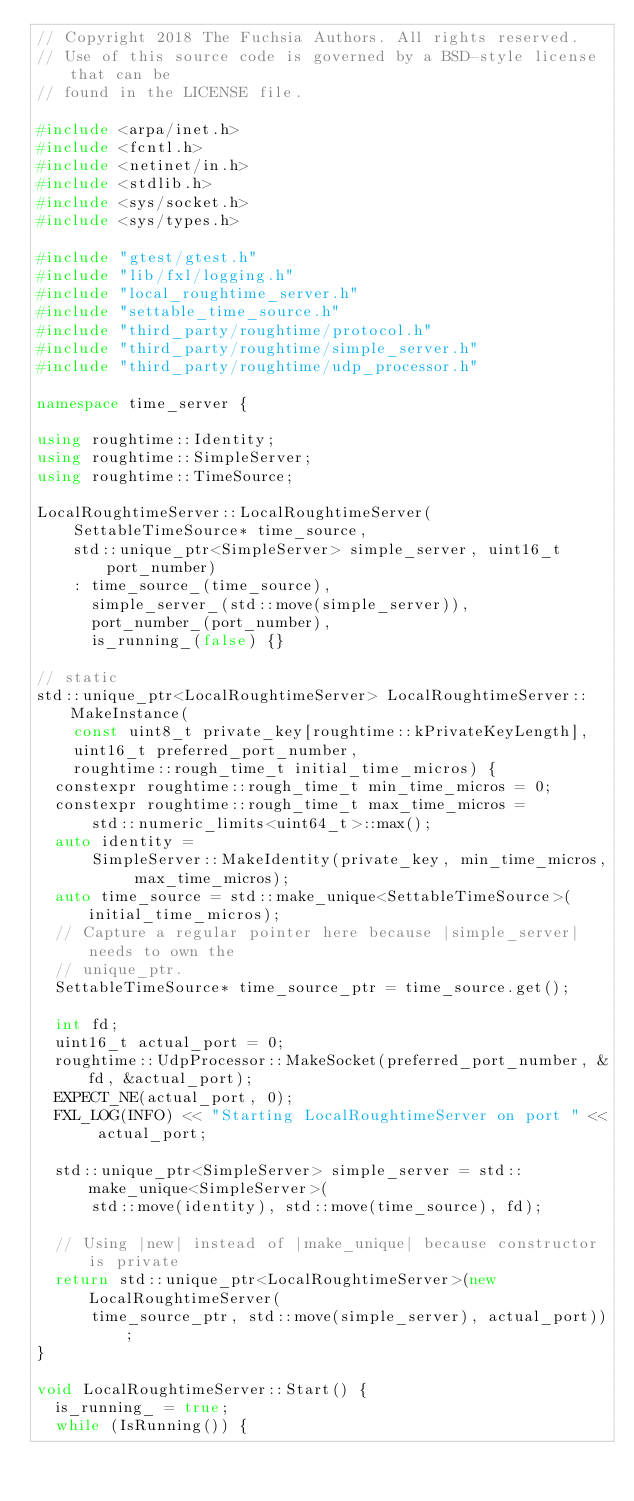Convert code to text. <code><loc_0><loc_0><loc_500><loc_500><_C++_>// Copyright 2018 The Fuchsia Authors. All rights reserved.
// Use of this source code is governed by a BSD-style license that can be
// found in the LICENSE file.

#include <arpa/inet.h>
#include <fcntl.h>
#include <netinet/in.h>
#include <stdlib.h>
#include <sys/socket.h>
#include <sys/types.h>

#include "gtest/gtest.h"
#include "lib/fxl/logging.h"
#include "local_roughtime_server.h"
#include "settable_time_source.h"
#include "third_party/roughtime/protocol.h"
#include "third_party/roughtime/simple_server.h"
#include "third_party/roughtime/udp_processor.h"

namespace time_server {

using roughtime::Identity;
using roughtime::SimpleServer;
using roughtime::TimeSource;

LocalRoughtimeServer::LocalRoughtimeServer(
    SettableTimeSource* time_source,
    std::unique_ptr<SimpleServer> simple_server, uint16_t port_number)
    : time_source_(time_source),
      simple_server_(std::move(simple_server)),
      port_number_(port_number),
      is_running_(false) {}

// static
std::unique_ptr<LocalRoughtimeServer> LocalRoughtimeServer::MakeInstance(
    const uint8_t private_key[roughtime::kPrivateKeyLength],
    uint16_t preferred_port_number,
    roughtime::rough_time_t initial_time_micros) {
  constexpr roughtime::rough_time_t min_time_micros = 0;
  constexpr roughtime::rough_time_t max_time_micros =
      std::numeric_limits<uint64_t>::max();
  auto identity =
      SimpleServer::MakeIdentity(private_key, min_time_micros, max_time_micros);
  auto time_source = std::make_unique<SettableTimeSource>(initial_time_micros);
  // Capture a regular pointer here because |simple_server| needs to own the
  // unique_ptr.
  SettableTimeSource* time_source_ptr = time_source.get();

  int fd;
  uint16_t actual_port = 0;
  roughtime::UdpProcessor::MakeSocket(preferred_port_number, &fd, &actual_port);
  EXPECT_NE(actual_port, 0);
  FXL_LOG(INFO) << "Starting LocalRoughtimeServer on port " << actual_port;

  std::unique_ptr<SimpleServer> simple_server = std::make_unique<SimpleServer>(
      std::move(identity), std::move(time_source), fd);

  // Using |new| instead of |make_unique| because constructor is private
  return std::unique_ptr<LocalRoughtimeServer>(new LocalRoughtimeServer(
      time_source_ptr, std::move(simple_server), actual_port));
}

void LocalRoughtimeServer::Start() {
  is_running_ = true;
  while (IsRunning()) {</code> 